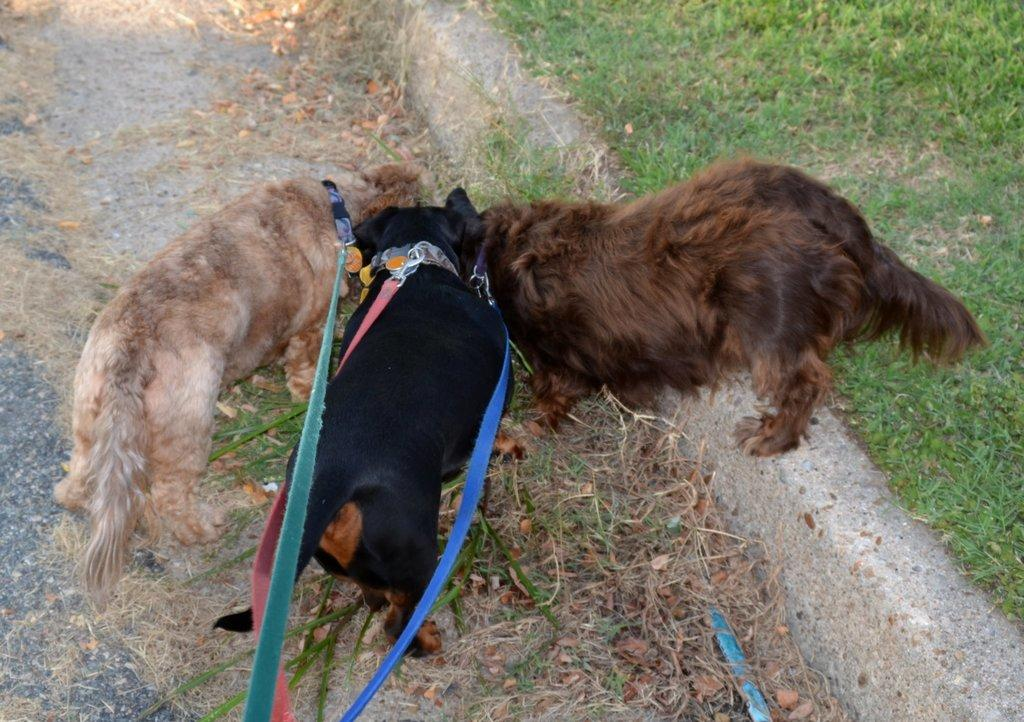How many dogs are present in the image? There are three dogs standing in the image. What accessories are visible on the dogs? Dog belts are visible in the image. What type of vegetation is present on the ground in the image? Dried grass and green grass are present in the image. What type of goose can be seen near the border in the image? There is no goose or border present in the image; it features three dogs and grass. 